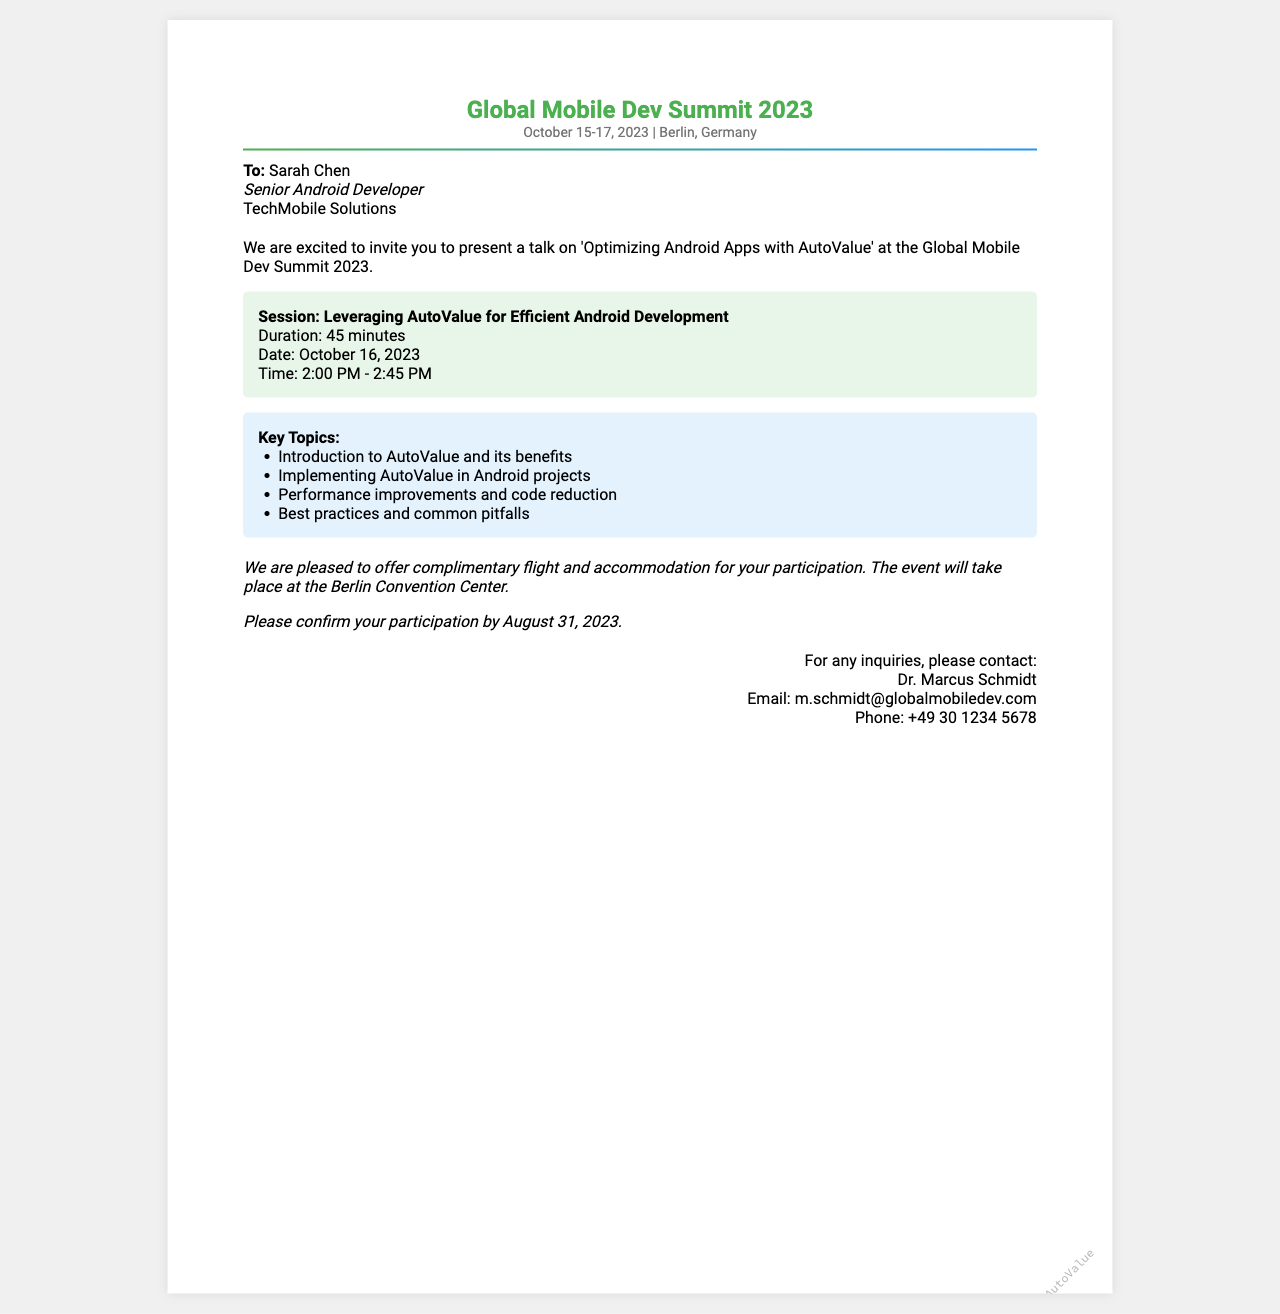What is the name of the event? The name of the event is highlighted in the document's header, which states “Global Mobile Dev Summit 2023.”
Answer: Global Mobile Dev Summit 2023 When will the event take place? The event dates are provided in the event details section, stating "October 15-17, 2023."
Answer: October 15-17, 2023 Who is the recipient of the invitation? The recipient's name is stated at the beginning of the document, identifying "Sarah Chen."
Answer: Sarah Chen What is the duration of the session? The session duration is specified as "45 minutes" in the session details.
Answer: 45 minutes What is the date of the session? The date of the session is clearly mentioned as "October 16, 2023" in the invitation body.
Answer: October 16, 2023 What key topic focuses on code reduction? One of the listed key topics in the document mentions "Performance improvements and code reduction."
Answer: Performance improvements and code reduction By what date must participation be confirmed? The document states that confirmation of participation should be completed by "August 31, 2023."
Answer: August 31, 2023 Who can be contacted for inquiries? The document specifies contact information for inquiries, naming "Dr. Marcus Schmidt."
Answer: Dr. Marcus Schmidt Where is the event being held? The logistics section states that the event will take place at the "Berlin Convention Center."
Answer: Berlin Convention Center 